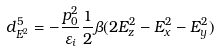Convert formula to latex. <formula><loc_0><loc_0><loc_500><loc_500>d ^ { 5 } _ { E ^ { 2 } } = - \frac { p ^ { 2 } _ { 0 } } { \varepsilon _ { i } } \frac { 1 } { 2 } \beta ( 2 E _ { z } ^ { 2 } - E _ { x } ^ { 2 } - E _ { y } ^ { 2 } )</formula> 